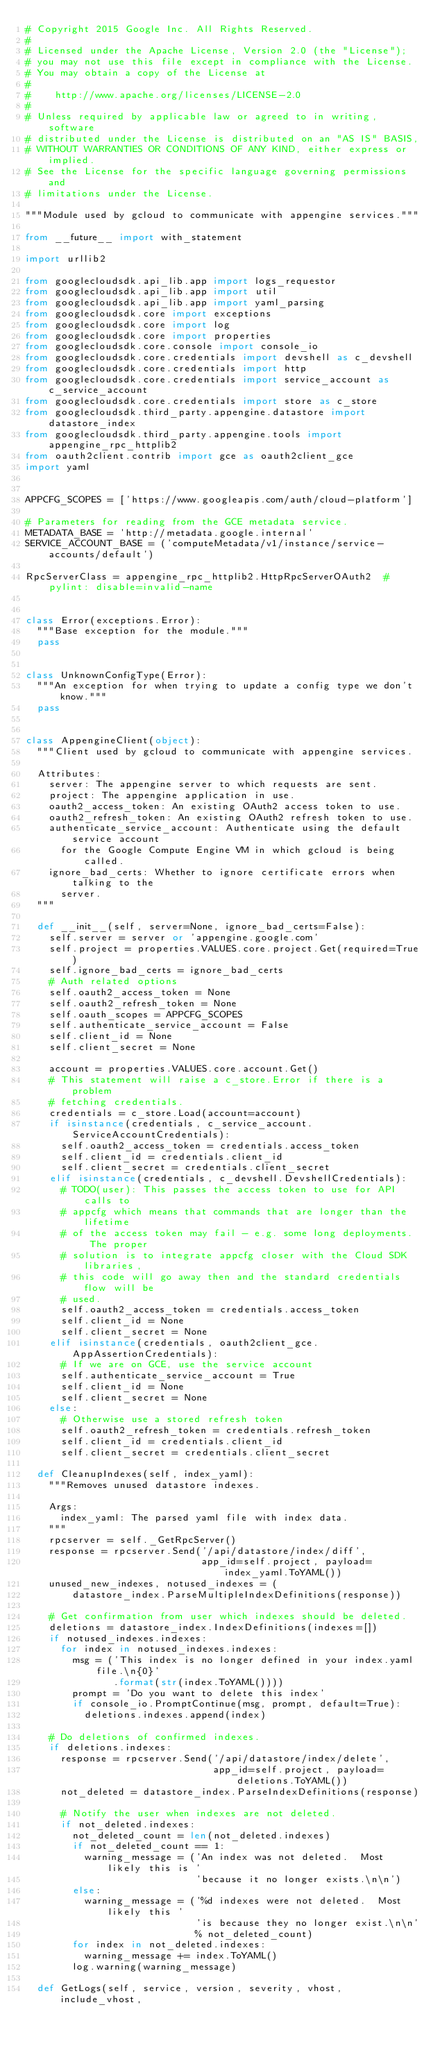Convert code to text. <code><loc_0><loc_0><loc_500><loc_500><_Python_># Copyright 2015 Google Inc. All Rights Reserved.
#
# Licensed under the Apache License, Version 2.0 (the "License");
# you may not use this file except in compliance with the License.
# You may obtain a copy of the License at
#
#    http://www.apache.org/licenses/LICENSE-2.0
#
# Unless required by applicable law or agreed to in writing, software
# distributed under the License is distributed on an "AS IS" BASIS,
# WITHOUT WARRANTIES OR CONDITIONS OF ANY KIND, either express or implied.
# See the License for the specific language governing permissions and
# limitations under the License.

"""Module used by gcloud to communicate with appengine services."""

from __future__ import with_statement

import urllib2

from googlecloudsdk.api_lib.app import logs_requestor
from googlecloudsdk.api_lib.app import util
from googlecloudsdk.api_lib.app import yaml_parsing
from googlecloudsdk.core import exceptions
from googlecloudsdk.core import log
from googlecloudsdk.core import properties
from googlecloudsdk.core.console import console_io
from googlecloudsdk.core.credentials import devshell as c_devshell
from googlecloudsdk.core.credentials import http
from googlecloudsdk.core.credentials import service_account as c_service_account
from googlecloudsdk.core.credentials import store as c_store
from googlecloudsdk.third_party.appengine.datastore import datastore_index
from googlecloudsdk.third_party.appengine.tools import appengine_rpc_httplib2
from oauth2client.contrib import gce as oauth2client_gce
import yaml


APPCFG_SCOPES = ['https://www.googleapis.com/auth/cloud-platform']

# Parameters for reading from the GCE metadata service.
METADATA_BASE = 'http://metadata.google.internal'
SERVICE_ACCOUNT_BASE = ('computeMetadata/v1/instance/service-accounts/default')

RpcServerClass = appengine_rpc_httplib2.HttpRpcServerOAuth2  # pylint: disable=invalid-name


class Error(exceptions.Error):
  """Base exception for the module."""
  pass


class UnknownConfigType(Error):
  """An exception for when trying to update a config type we don't know."""
  pass


class AppengineClient(object):
  """Client used by gcloud to communicate with appengine services.

  Attributes:
    server: The appengine server to which requests are sent.
    project: The appengine application in use.
    oauth2_access_token: An existing OAuth2 access token to use.
    oauth2_refresh_token: An existing OAuth2 refresh token to use.
    authenticate_service_account: Authenticate using the default service account
      for the Google Compute Engine VM in which gcloud is being called.
    ignore_bad_certs: Whether to ignore certificate errors when talking to the
      server.
  """

  def __init__(self, server=None, ignore_bad_certs=False):
    self.server = server or 'appengine.google.com'
    self.project = properties.VALUES.core.project.Get(required=True)
    self.ignore_bad_certs = ignore_bad_certs
    # Auth related options
    self.oauth2_access_token = None
    self.oauth2_refresh_token = None
    self.oauth_scopes = APPCFG_SCOPES
    self.authenticate_service_account = False
    self.client_id = None
    self.client_secret = None

    account = properties.VALUES.core.account.Get()
    # This statement will raise a c_store.Error if there is a problem
    # fetching credentials.
    credentials = c_store.Load(account=account)
    if isinstance(credentials, c_service_account.ServiceAccountCredentials):
      self.oauth2_access_token = credentials.access_token
      self.client_id = credentials.client_id
      self.client_secret = credentials.client_secret
    elif isinstance(credentials, c_devshell.DevshellCredentials):
      # TODO(user): This passes the access token to use for API calls to
      # appcfg which means that commands that are longer than the lifetime
      # of the access token may fail - e.g. some long deployments.  The proper
      # solution is to integrate appcfg closer with the Cloud SDK libraries,
      # this code will go away then and the standard credentials flow will be
      # used.
      self.oauth2_access_token = credentials.access_token
      self.client_id = None
      self.client_secret = None
    elif isinstance(credentials, oauth2client_gce.AppAssertionCredentials):
      # If we are on GCE, use the service account
      self.authenticate_service_account = True
      self.client_id = None
      self.client_secret = None
    else:
      # Otherwise use a stored refresh token
      self.oauth2_refresh_token = credentials.refresh_token
      self.client_id = credentials.client_id
      self.client_secret = credentials.client_secret

  def CleanupIndexes(self, index_yaml):
    """Removes unused datastore indexes.

    Args:
      index_yaml: The parsed yaml file with index data.
    """
    rpcserver = self._GetRpcServer()
    response = rpcserver.Send('/api/datastore/index/diff',
                              app_id=self.project, payload=index_yaml.ToYAML())
    unused_new_indexes, notused_indexes = (
        datastore_index.ParseMultipleIndexDefinitions(response))

    # Get confirmation from user which indexes should be deleted.
    deletions = datastore_index.IndexDefinitions(indexes=[])
    if notused_indexes.indexes:
      for index in notused_indexes.indexes:
        msg = ('This index is no longer defined in your index.yaml file.\n{0}'
               .format(str(index.ToYAML())))
        prompt = 'Do you want to delete this index'
        if console_io.PromptContinue(msg, prompt, default=True):
          deletions.indexes.append(index)

    # Do deletions of confirmed indexes.
    if deletions.indexes:
      response = rpcserver.Send('/api/datastore/index/delete',
                                app_id=self.project, payload=deletions.ToYAML())
      not_deleted = datastore_index.ParseIndexDefinitions(response)

      # Notify the user when indexes are not deleted.
      if not_deleted.indexes:
        not_deleted_count = len(not_deleted.indexes)
        if not_deleted_count == 1:
          warning_message = ('An index was not deleted.  Most likely this is '
                             'because it no longer exists.\n\n')
        else:
          warning_message = ('%d indexes were not deleted.  Most likely this '
                             'is because they no longer exist.\n\n'
                             % not_deleted_count)
        for index in not_deleted.indexes:
          warning_message += index.ToYAML()
        log.warning(warning_message)

  def GetLogs(self, service, version, severity, vhost, include_vhost,</code> 